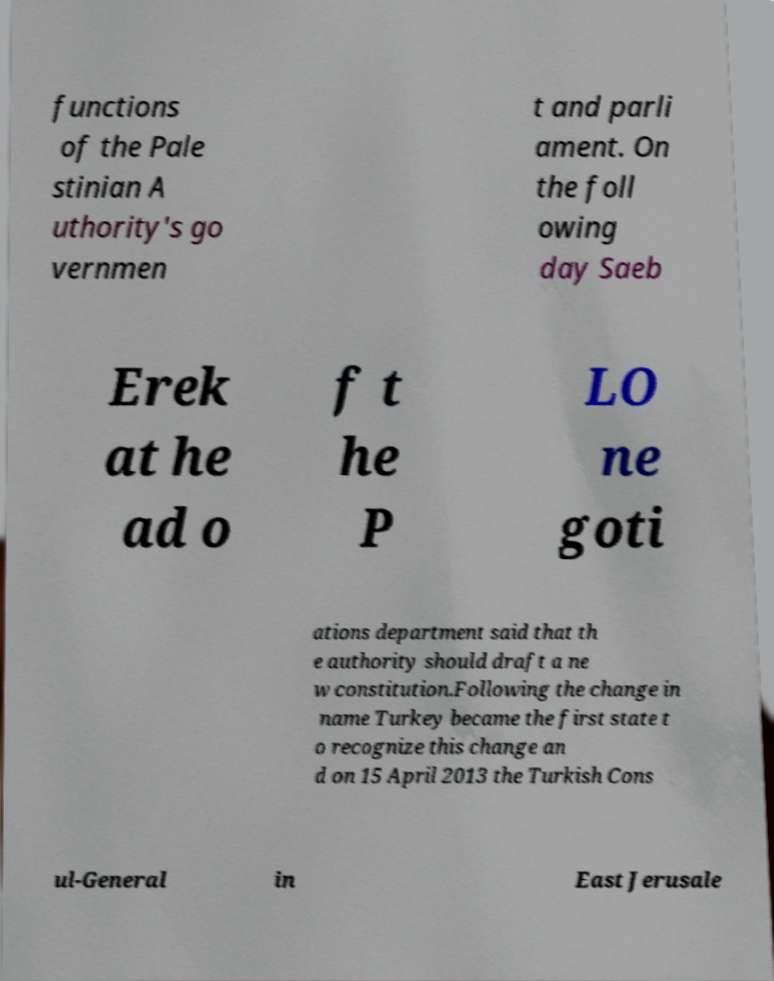Please read and relay the text visible in this image. What does it say? functions of the Pale stinian A uthority's go vernmen t and parli ament. On the foll owing day Saeb Erek at he ad o f t he P LO ne goti ations department said that th e authority should draft a ne w constitution.Following the change in name Turkey became the first state t o recognize this change an d on 15 April 2013 the Turkish Cons ul-General in East Jerusale 